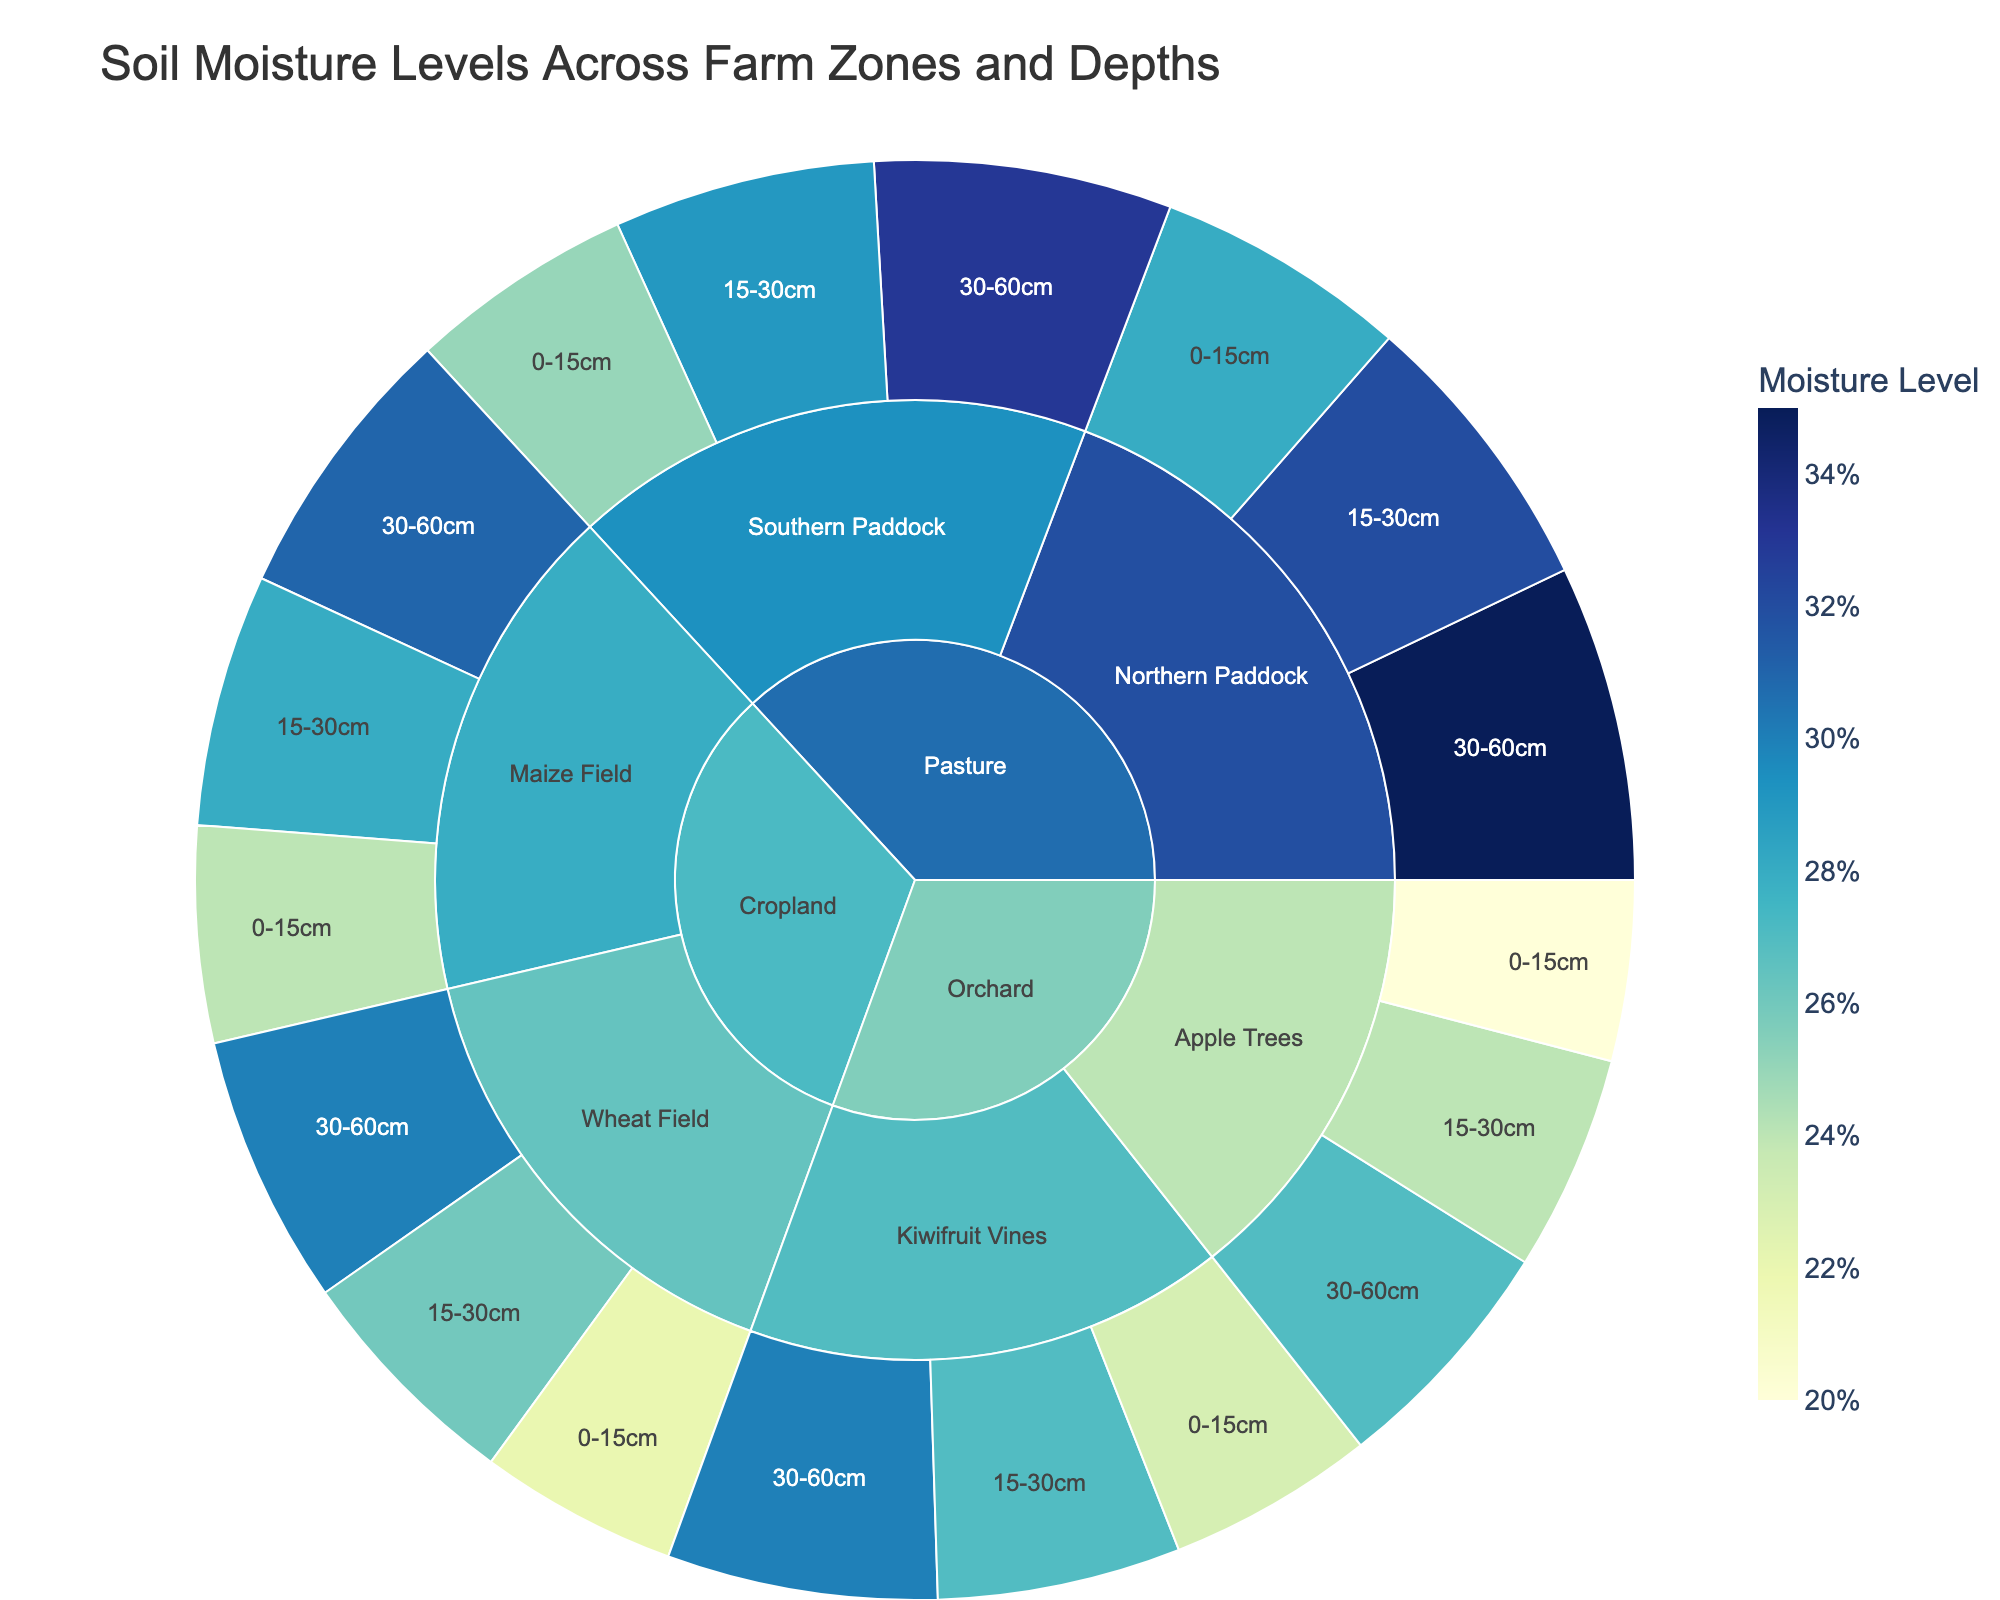what is the title of the plot? The title of the plot is displayed at the top center of the figure and describes what the plot visualizes. The exact text that appears as the title is "Soil Moisture Levels Across Farm Zones and Depths".
Answer: Soil Moisture Levels Across Farm Zones and Depths What zone has the highest soil moisture level? To determine the zone with the highest soil moisture level, we need to examine each zone's segments and locate the one with the highest moisture level. The Pasture zone has the highest soil moisture level at 35% in the Northern Paddock at a depth of 30-60cm.
Answer: Pasture What's the average soil moisture level in the Orchard zone? To find the average soil moisture level in the Orchard zone, we locate all the moisture levels in the Orchard segments and compute their average. The Orchard zone has moisture levels of 20, 24, 27, 23, 27, and 30. Adding them gives 151, and dividing by 6 gives 25.17%.
Answer: 25.17% Which subzone has the lowest soil moisture level in the Cropland zone? To find the subzone in the Cropland zone with the lowest moisture level, examine each subzone's segments. The Wheat Field has the lowest soil moisture level at 22% in the 0-15cm depth.
Answer: Wheat Field How much is the difference in soil moisture levels between the Northern and Southern Paddocks in the Pasture zone at a depth of 30-60cm? To find the difference, subtract the moisture level of the Southern Paddock from the Northern Paddock at the 30-60cm depth. The Northern Paddock has a moisture level of 35%, and the Southern Paddock has 33%. The difference is 35 - 33 = 2%.
Answer: 2% What is the total moisture level for the 0-15cm depth across all zones? To find the total moisture level for the 0-15cm depth, we need to sum the moisture levels in this depth across all zones. The values are 28, 25, 22, 24, 20, 23. Summing them gives 142%.
Answer: 142% Which zone has the most uniform distribution of soil moisture levels across its subzones and depths? To determine uniformity, we look for the zone where the moisture levels have the least variation across subzones and depths. The Orchard zone has relatively uniform moisture levels: 20, 24, 27, 23, 27, and 30. The differences among these values are smaller compared to other zones.
Answer: Orchard What is the median soil moisture level for the Orchard zone? To determine the median soil moisture level, we order the moisture levels of the Orchard zone and find the middle value(s). The levels are 20, 23, 24, 27, 27, 30. The median is the average of the 3rd and 4th values: (24 + 27)/2 = 25.5%.
Answer: 25.5% 